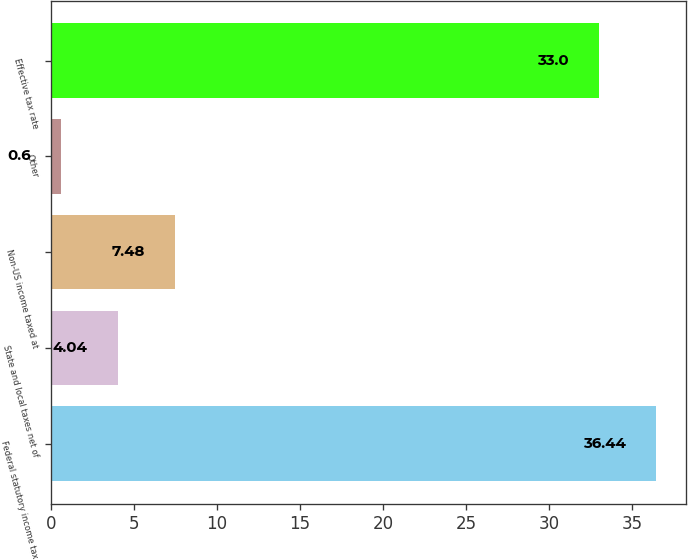Convert chart. <chart><loc_0><loc_0><loc_500><loc_500><bar_chart><fcel>Federal statutory income tax<fcel>State and local taxes net of<fcel>Non-US income taxed at<fcel>Other<fcel>Effective tax rate<nl><fcel>36.44<fcel>4.04<fcel>7.48<fcel>0.6<fcel>33<nl></chart> 